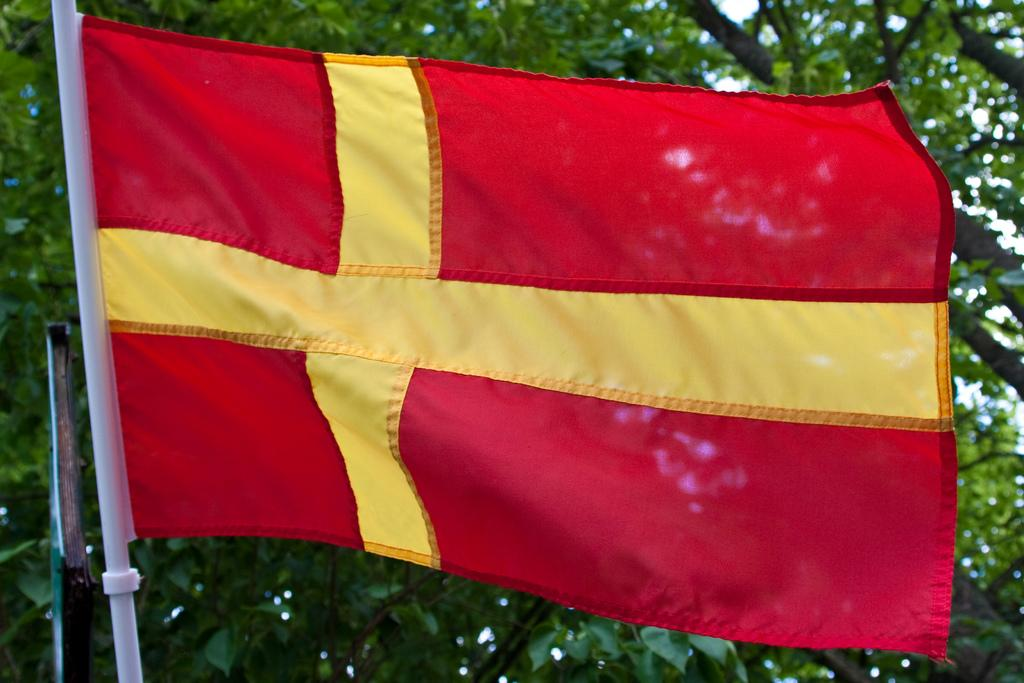What is the main object in the image? There is a flag in the image. What can be seen in the background of the image? There are trees in the background of the image. How many docks are visible in the image? There are no docks present in the image. What type of birds can be seen flying in the image? There are no birds visible in the image. 